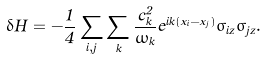<formula> <loc_0><loc_0><loc_500><loc_500>\delta H = - \frac { 1 } { 4 } \sum _ { i , j } \sum _ { k } \frac { c _ { k } ^ { 2 } } { \omega _ { k } } e ^ { i k ( x _ { i } - x _ { j } ) } \sigma _ { i z } \sigma _ { j z } .</formula> 